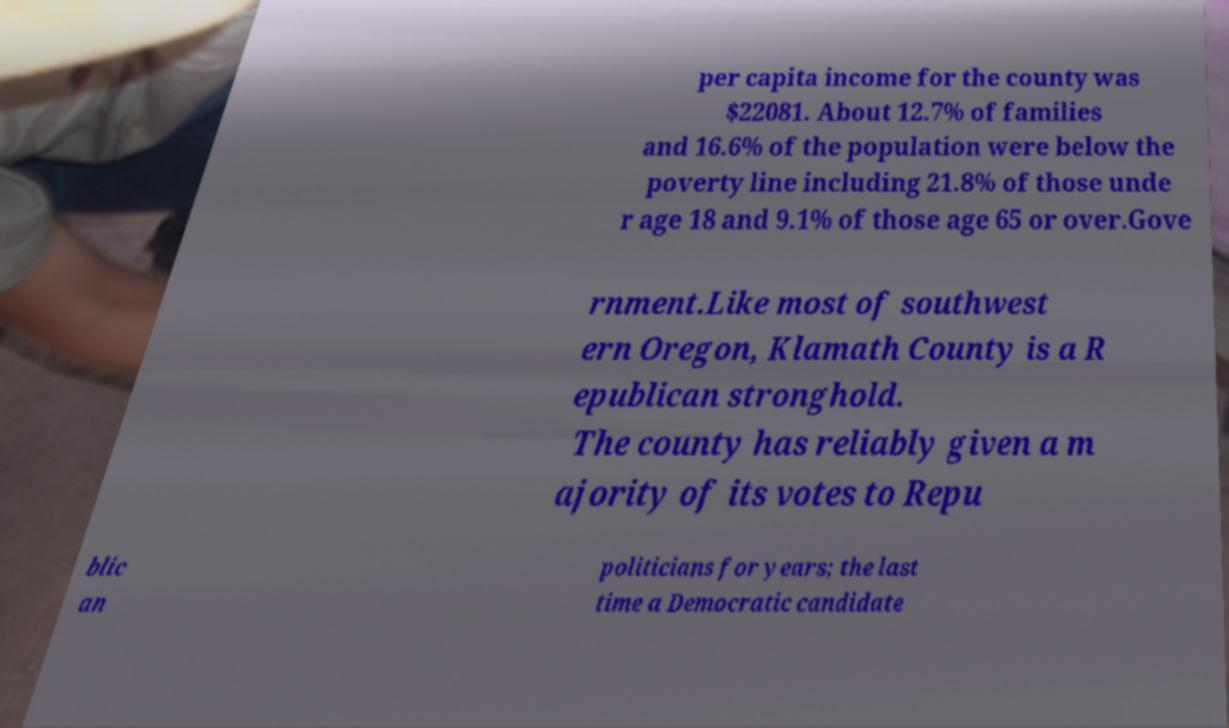There's text embedded in this image that I need extracted. Can you transcribe it verbatim? per capita income for the county was $22081. About 12.7% of families and 16.6% of the population were below the poverty line including 21.8% of those unde r age 18 and 9.1% of those age 65 or over.Gove rnment.Like most of southwest ern Oregon, Klamath County is a R epublican stronghold. The county has reliably given a m ajority of its votes to Repu blic an politicians for years; the last time a Democratic candidate 